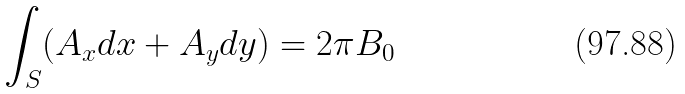Convert formula to latex. <formula><loc_0><loc_0><loc_500><loc_500>\int _ { S } ( A _ { x } d x + A _ { y } d y ) = 2 \pi B _ { 0 }</formula> 